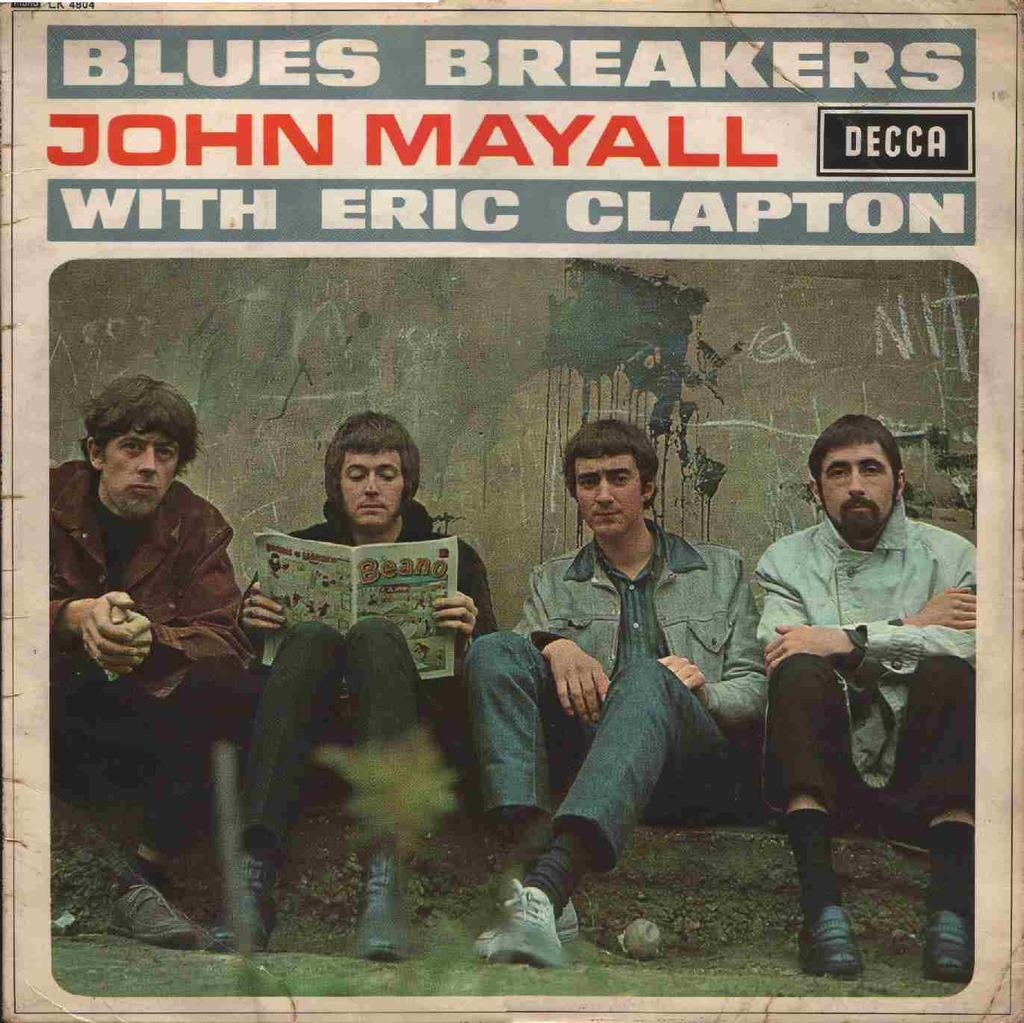What is featured on the poster in the image? The poster contains text and an image of persons sitting on the ground. Can you describe the text on the poster? Unfortunately, the specific content of the text cannot be determined from the image. What is the person holding in the image? The person is holding a book in the image. What is visible behind the persons in the image? There is a wall behind the persons in the image. What type of pancake is being served on the wall in the image? There is no pancake present in the image, and the wall does not appear to be serving any food. 